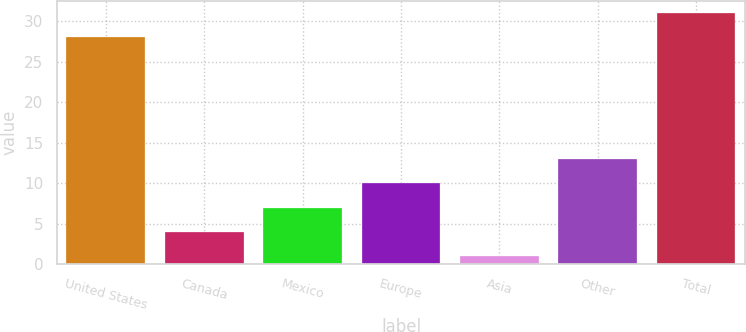Convert chart. <chart><loc_0><loc_0><loc_500><loc_500><bar_chart><fcel>United States<fcel>Canada<fcel>Mexico<fcel>Europe<fcel>Asia<fcel>Other<fcel>Total<nl><fcel>28<fcel>4<fcel>7<fcel>10<fcel>1<fcel>13<fcel>31<nl></chart> 